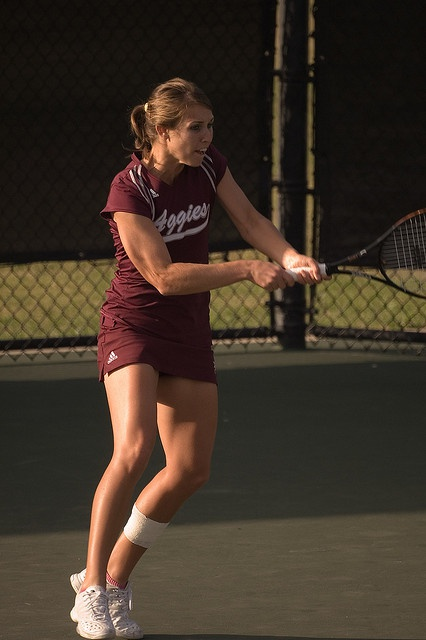Describe the objects in this image and their specific colors. I can see people in black, maroon, and brown tones and tennis racket in black and gray tones in this image. 